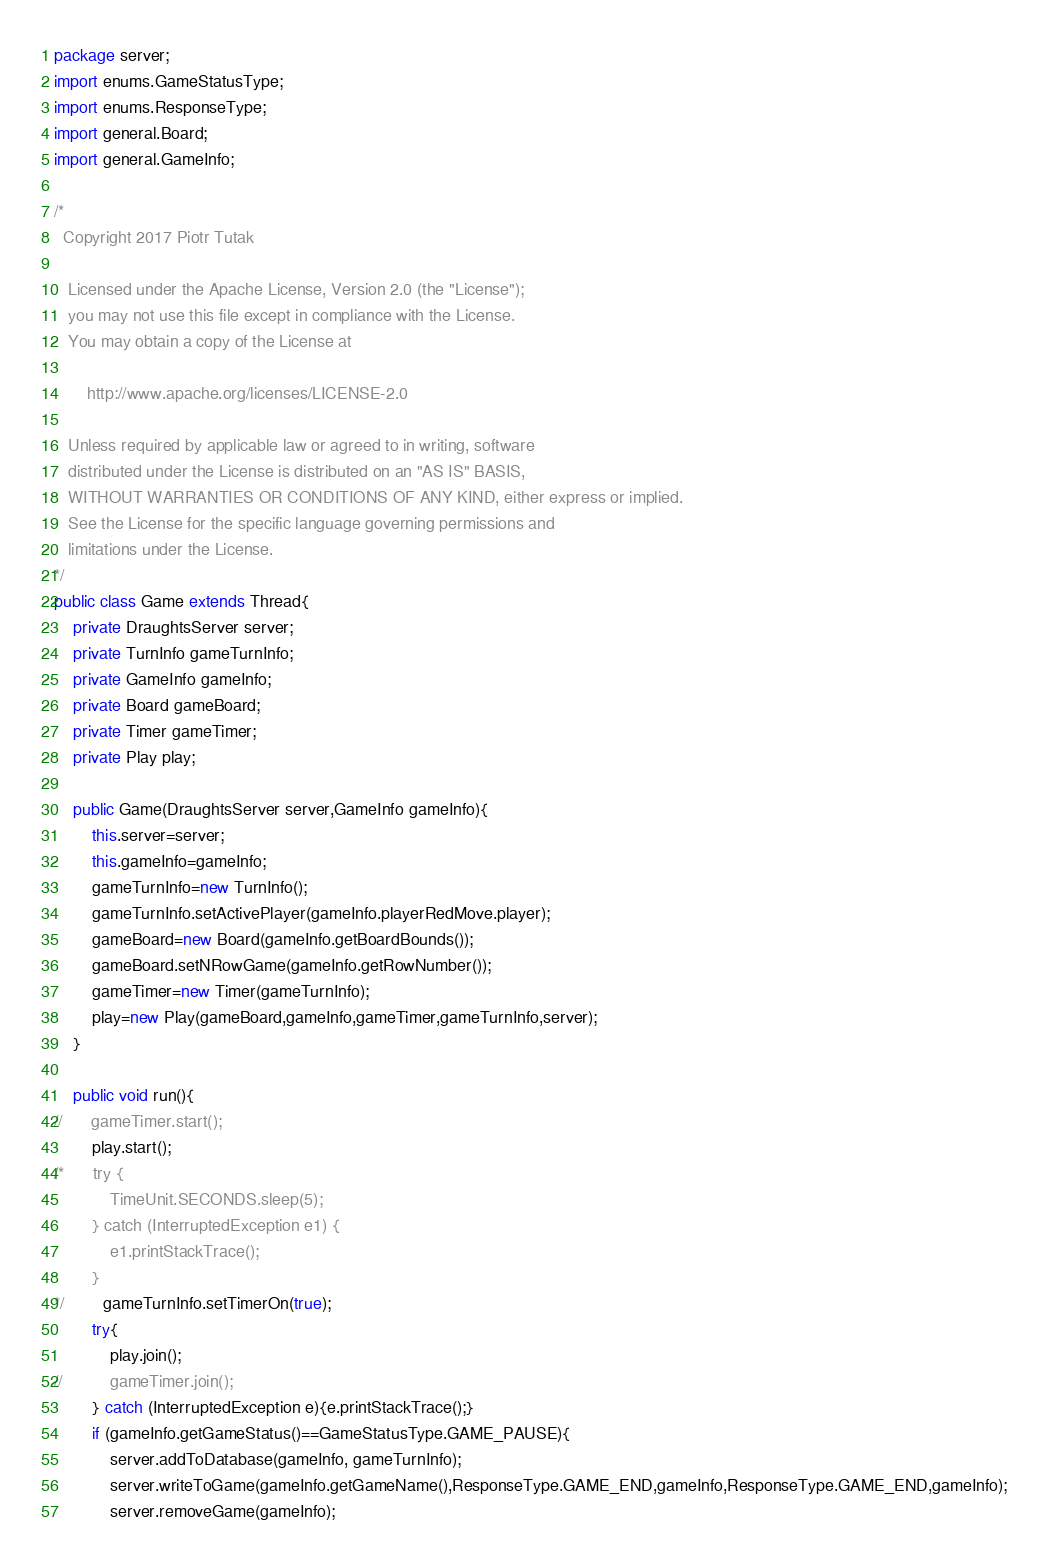<code> <loc_0><loc_0><loc_500><loc_500><_Java_>package server;
import enums.GameStatusType;
import enums.ResponseType;
import general.Board;
import general.GameInfo;

/* 
  Copyright 2017 Piotr Tutak
 
   Licensed under the Apache License, Version 2.0 (the "License");
   you may not use this file except in compliance with the License.
   You may obtain a copy of the License at

       http://www.apache.org/licenses/LICENSE-2.0

   Unless required by applicable law or agreed to in writing, software
   distributed under the License is distributed on an "AS IS" BASIS,
   WITHOUT WARRANTIES OR CONDITIONS OF ANY KIND, either express or implied.
   See the License for the specific language governing permissions and
   limitations under the License.
*/
public class Game extends Thread{
	private DraughtsServer server;
	private TurnInfo gameTurnInfo;
	private GameInfo gameInfo;
	private Board gameBoard;
	private Timer gameTimer;
	private Play play;
	
	public Game(DraughtsServer server,GameInfo gameInfo){
		this.server=server;
		this.gameInfo=gameInfo;
		gameTurnInfo=new TurnInfo();
		gameTurnInfo.setActivePlayer(gameInfo.playerRedMove.player);
		gameBoard=new Board(gameInfo.getBoardBounds());
		gameBoard.setNRowGame(gameInfo.getRowNumber());
		gameTimer=new Timer(gameTurnInfo);
		play=new Play(gameBoard,gameInfo,gameTimer,gameTurnInfo,server);
	}
	
	public void run(){
//		gameTimer.start();
		play.start();
/*		try {
			TimeUnit.SECONDS.sleep(5);
		} catch (InterruptedException e1) {
			e1.printStackTrace();
		}
*/		gameTurnInfo.setTimerOn(true);
		try{
			play.join();
//			gameTimer.join();
		} catch (InterruptedException e){e.printStackTrace();}
		if (gameInfo.getGameStatus()==GameStatusType.GAME_PAUSE){
			server.addToDatabase(gameInfo, gameTurnInfo);
			server.writeToGame(gameInfo.getGameName(),ResponseType.GAME_END,gameInfo,ResponseType.GAME_END,gameInfo);
			server.removeGame(gameInfo);</code> 